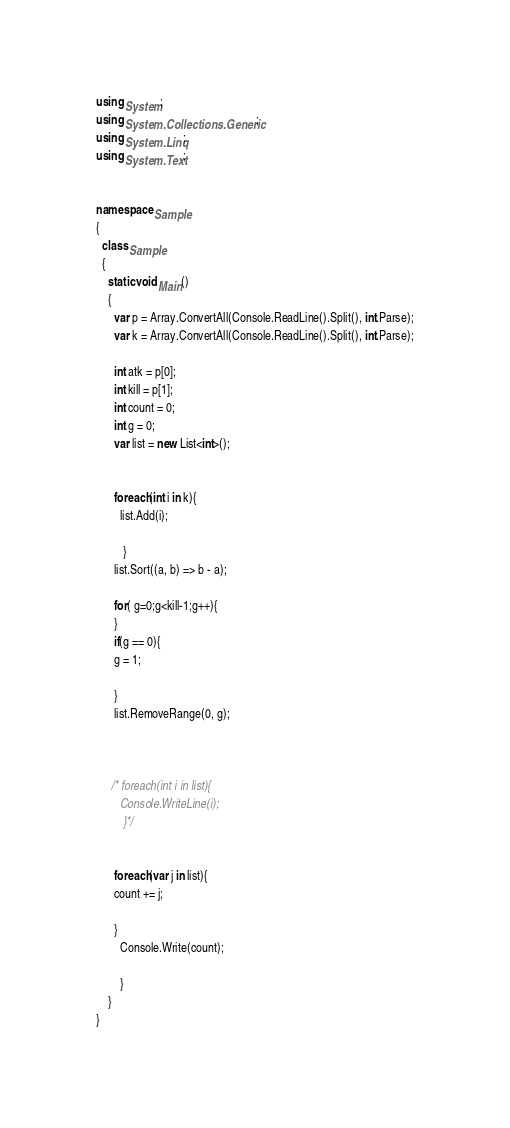<code> <loc_0><loc_0><loc_500><loc_500><_C#_>using System;
using System.Collections.Generic;
using System.Linq;
using System.Text;


namespace Sample
{
  class Sample
  {
    static void Main()
    {
      var p = Array.ConvertAll(Console.ReadLine().Split(), int.Parse);
      var k = Array.ConvertAll(Console.ReadLine().Split(), int.Parse);
      
      int atk = p[0];
      int kill = p[1];
      int count = 0;
      int g = 0;
      var list = new List<int>();
      	
      
      foreach(int i in k){
      	list.Add(i);  
     
         }
      list.Sort((a, b) => b - a);

      for( g=0;g<kill-1;g++){
      }
      if(g == 0){
      g = 1;
      
      }
      list.RemoveRange(0, g);

      
      
     /* foreach(int i in list){
        Console.WriteLine(i);
         }*/
      
      
      foreach(var j in list){
      count += j;
      
      }
		Console.Write(count);
      
		}
	}
}
</code> 